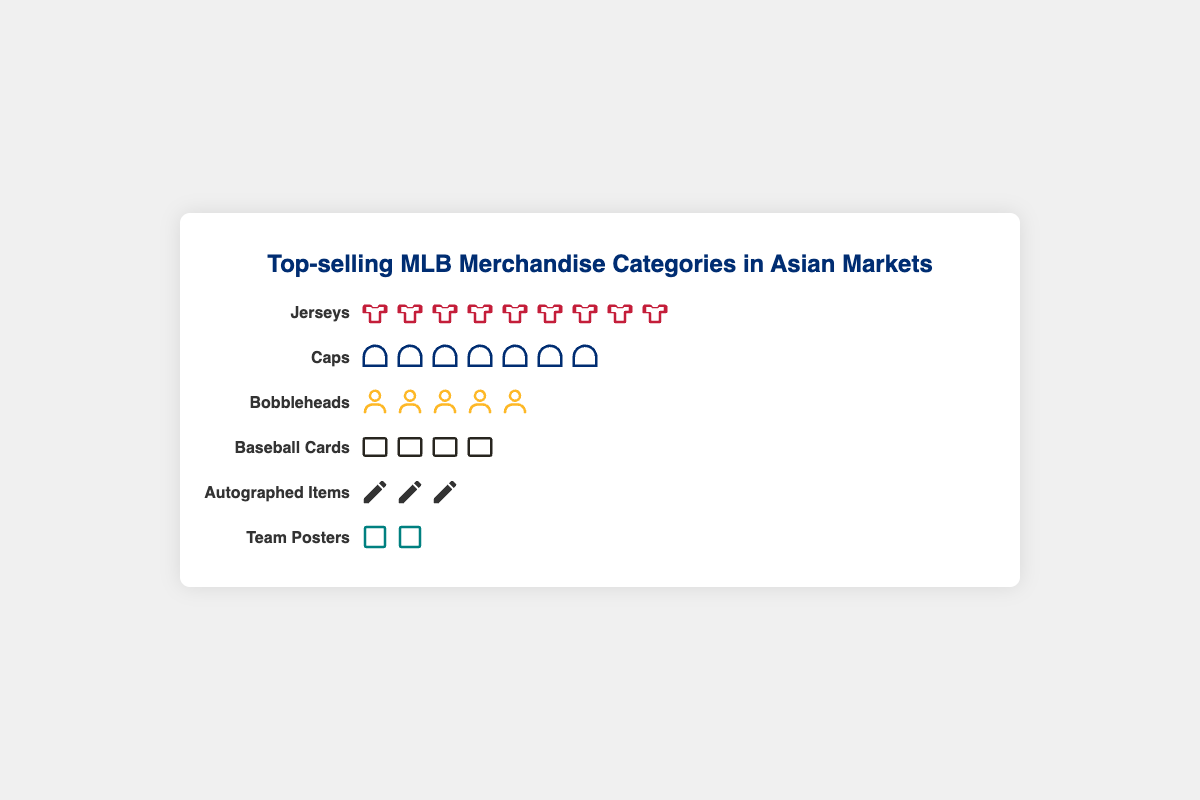Which MLB merchandise category has the highest sales in Asian markets? The category with the highest sales has the most icons in the figure. The "Jerseys" category has the most icons, indicating it has the highest sales.
Answer: Jerseys How many sales are represented by the icons for the "Caps" category? Each icon represents a certain number of sales specific to each category. The "Caps" category has 7 icons.
Answer: 35 sales What is the sales difference between the "Jerseys" and "Caps" categories? The "Jerseys" category has 9 icons, and the "Caps" category has 7 icons. Each icon represents a total of 5 sales. The difference is (9-7) * 5.
Answer: 10 sales Which category sells fewer items, "Bobbleheads" or "Autographed Items"? In the figure, count the number of icons for each category. "Bobbleheads" has 5 icons, and "Autographed Items" has 3 icons.
Answer: Autographed Items What is the total number of sales for "Baseball Cards" and "Team Posters"? Add the number of sales from both categories by counting the icons in each. "Baseball Cards" has 4 icons, and "Team Posters" has 2 icons. Thus, (4 + 2) * 5.
Answer: 30 sales Which category has one more icon than "Baseball Cards"? Determine the number of icons in "Baseball Cards," which is 4. Then, look for the category with 5 icons. The "Bobbleheads" category fits.
Answer: Bobbleheads How many icons in total are there in the figure across all categories? Sum the number of icons for each category: "Jerseys" (9), "Caps" (7), "Bobbleheads" (5), "Baseball Cards" (4), "Autographed Items" (3), "Team Posters" (2). Total = 9 + 7 + 5 + 4 + 3 + 2.
Answer: 30 icons In terms of sales volume, which categories are equal to less than 20 sales? Count the number of icons each category has to determine their sales: "Autographed Items" (3 icons), "Team Posters" (2 icons). Both have fewer than 20 sales each (3x5 = 15 and 2x5 = 10).
Answer: Team Posters, Autographed Items 